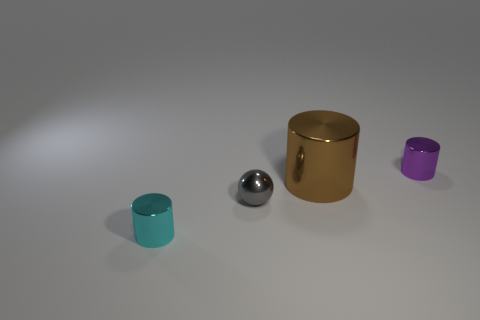If these objects were representative of a family, could you assign roles to them and explain? If we were to anthropomorphize these objects into a family unit, the large brown cylinder could represent a parent due to its size and protective-looking stature. The silver sphere might be an elder sibling, its reflective nature implying wisdom and a multifaceted personality. The smaller teal and purple cylinders could be younger siblings, perhaps twins, with vibrant, playful colors and a similar size indicating closeness in age and interests. 